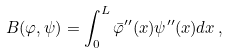<formula> <loc_0><loc_0><loc_500><loc_500>B ( \varphi , \psi ) = \int _ { 0 } ^ { L } \bar { \varphi } ^ { \prime \prime } ( x ) \psi ^ { \prime \prime } ( x ) d x \, ,</formula> 